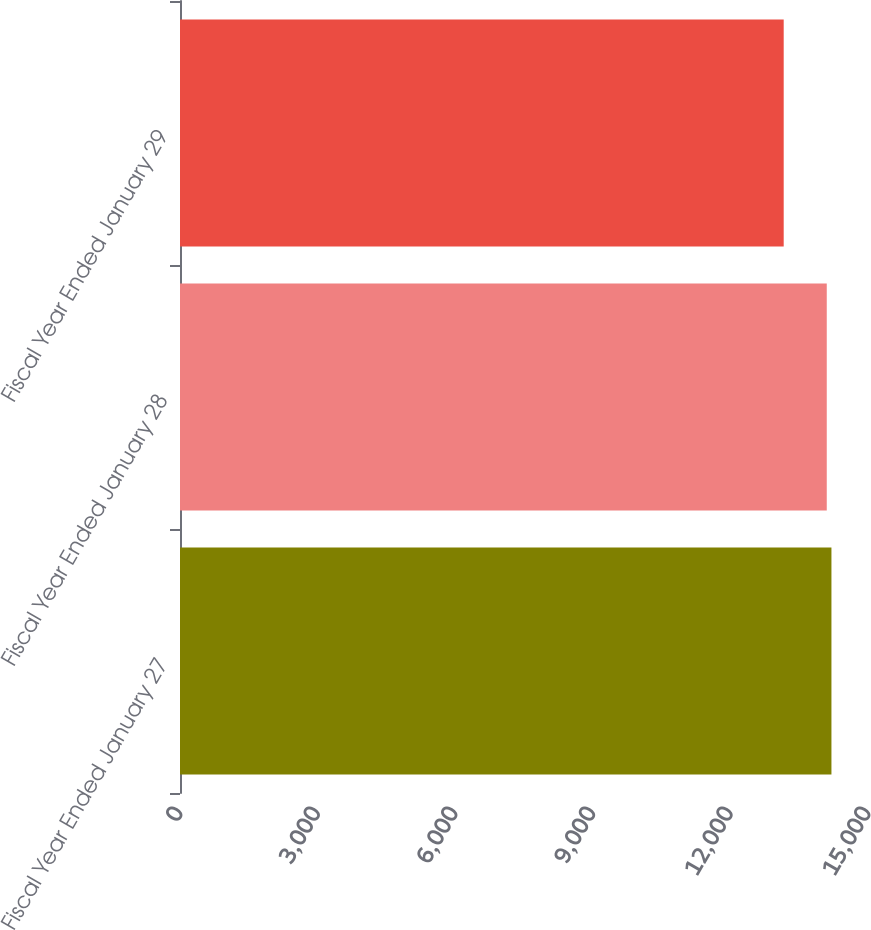Convert chart to OTSL. <chart><loc_0><loc_0><loc_500><loc_500><bar_chart><fcel>Fiscal Year Ended January 27<fcel>Fiscal Year Ended January 28<fcel>Fiscal Year Ended January 29<nl><fcel>14203<fcel>14101<fcel>13162<nl></chart> 